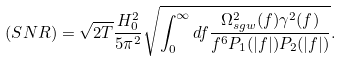Convert formula to latex. <formula><loc_0><loc_0><loc_500><loc_500>( S N R ) = \sqrt { 2 T } \frac { H _ { 0 } ^ { 2 } } { 5 \pi ^ { 2 } } \sqrt { \int _ { 0 } ^ { \infty } d f \frac { \Omega _ { s g w } ^ { 2 } ( f ) \gamma ^ { 2 } ( f ) } { f ^ { 6 } P _ { 1 } ( | f | ) P _ { 2 } ( | f | ) } } .</formula> 